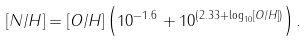<formula> <loc_0><loc_0><loc_500><loc_500>\left [ N / H \right ] = \left [ O / H \right ] \left ( 1 0 ^ { - 1 . 6 } + 1 0 ^ { \left ( 2 . 3 3 + \log _ { 1 0 } \left [ O / H \right ] \right ) } \right ) .</formula> 